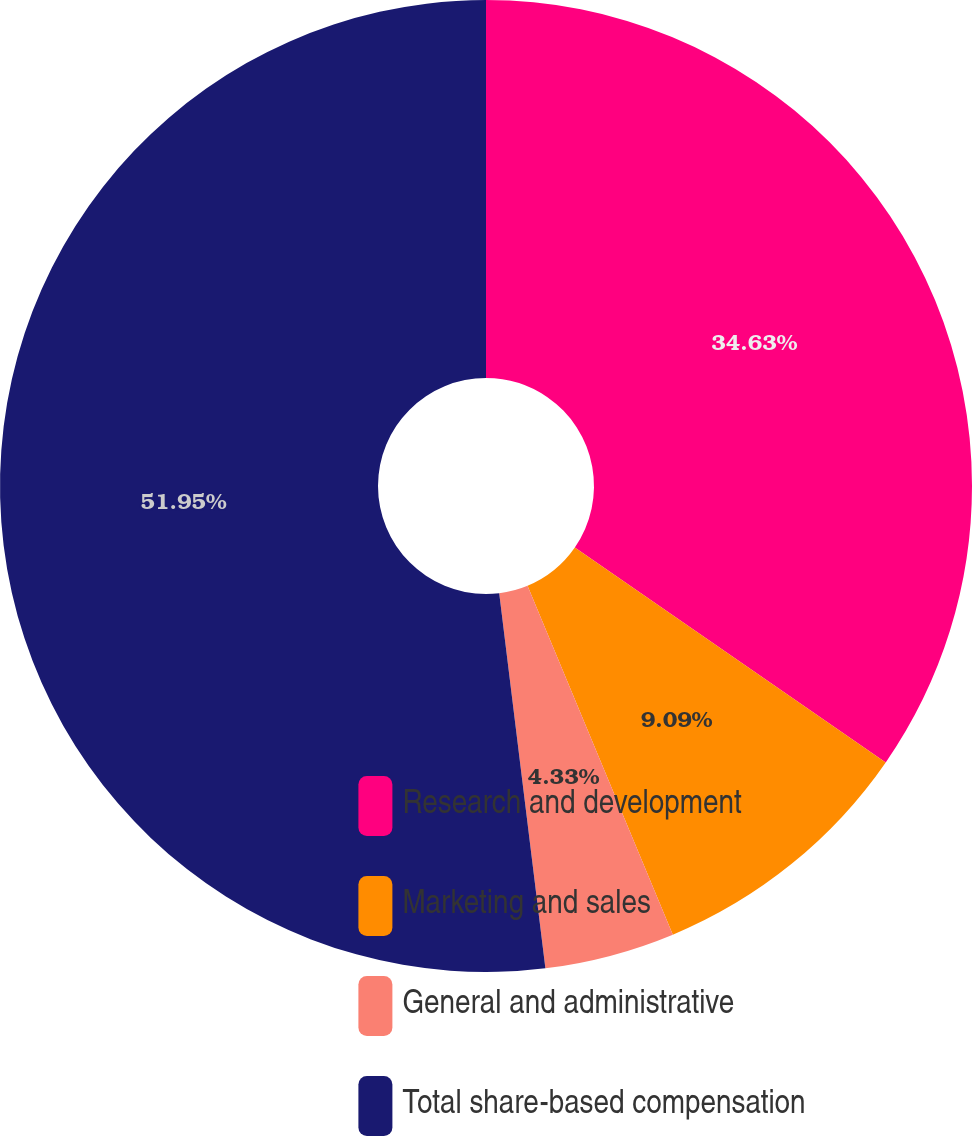<chart> <loc_0><loc_0><loc_500><loc_500><pie_chart><fcel>Research and development<fcel>Marketing and sales<fcel>General and administrative<fcel>Total share-based compensation<nl><fcel>34.63%<fcel>9.09%<fcel>4.33%<fcel>51.95%<nl></chart> 